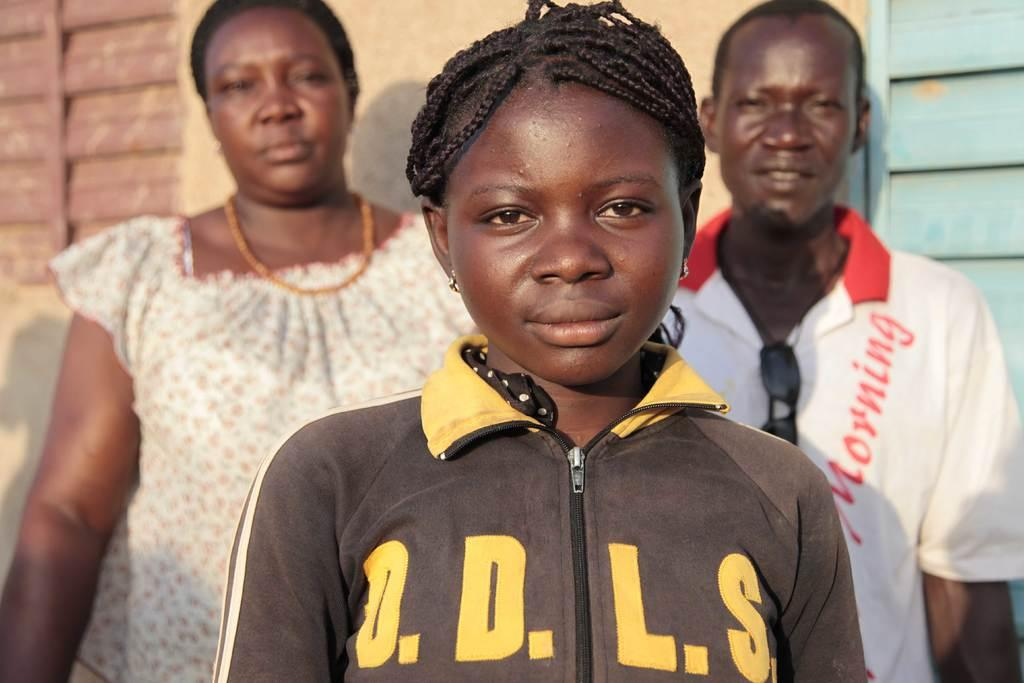Who is the main subject in the image? There is a girl in the center of the image. Can you describe the people in the background? There is a lady and a man in the background of the image. What is visible behind the people in the image? There is a wall in the background of the image. What type of lettuce is being used for the treatment in the image? There is no lettuce or treatment present in the image. 